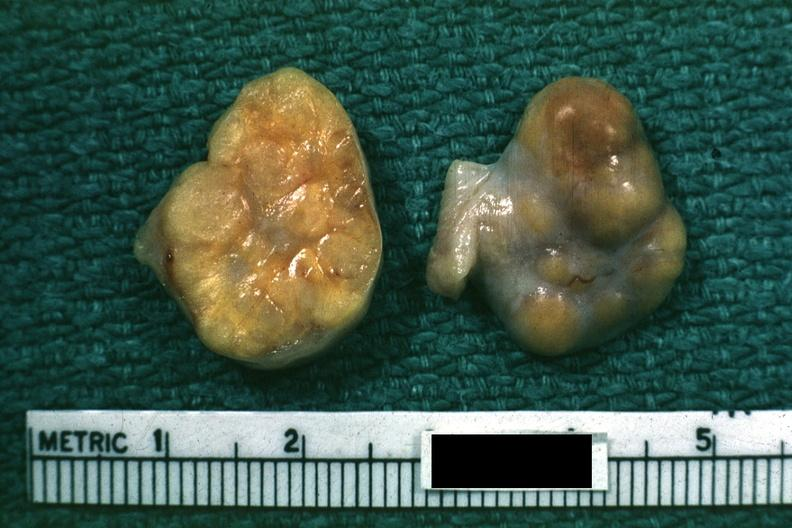does yellow color indicate theca cells can not recognize as ovary?
Answer the question using a single word or phrase. Yes 